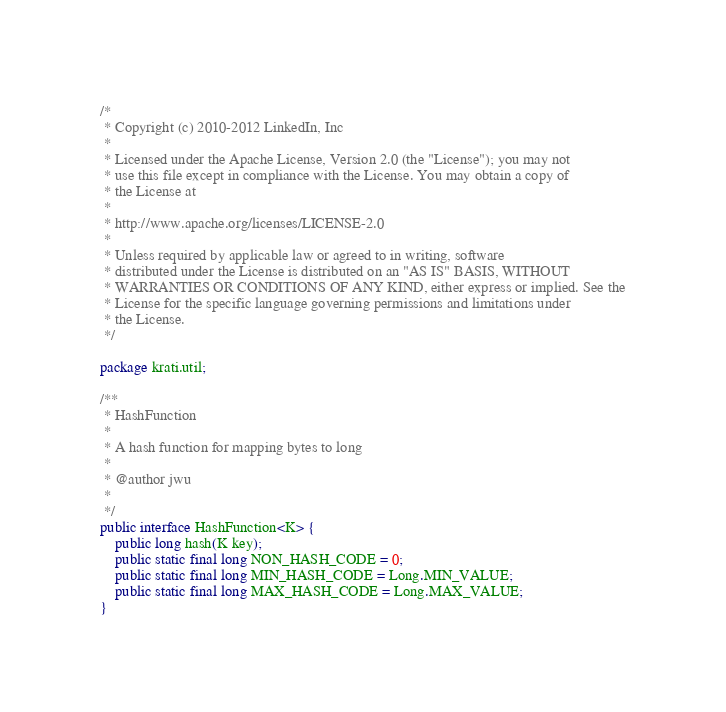Convert code to text. <code><loc_0><loc_0><loc_500><loc_500><_Java_>/*
 * Copyright (c) 2010-2012 LinkedIn, Inc
 * 
 * Licensed under the Apache License, Version 2.0 (the "License"); you may not
 * use this file except in compliance with the License. You may obtain a copy of
 * the License at
 * 
 * http://www.apache.org/licenses/LICENSE-2.0
 * 
 * Unless required by applicable law or agreed to in writing, software
 * distributed under the License is distributed on an "AS IS" BASIS, WITHOUT
 * WARRANTIES OR CONDITIONS OF ANY KIND, either express or implied. See the
 * License for the specific language governing permissions and limitations under
 * the License.
 */

package krati.util;

/**
 * HashFunction
 * 
 * A hash function for mapping bytes to long
 * 
 * @author jwu
 *
 */
public interface HashFunction<K> {
    public long hash(K key);
    public static final long NON_HASH_CODE = 0;
    public static final long MIN_HASH_CODE = Long.MIN_VALUE;
    public static final long MAX_HASH_CODE = Long.MAX_VALUE;
}
</code> 